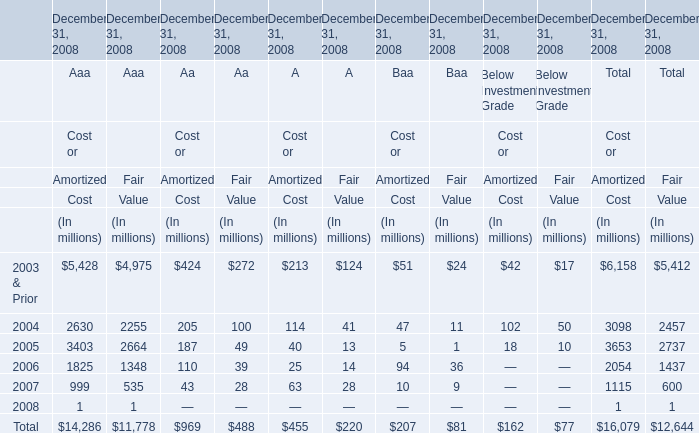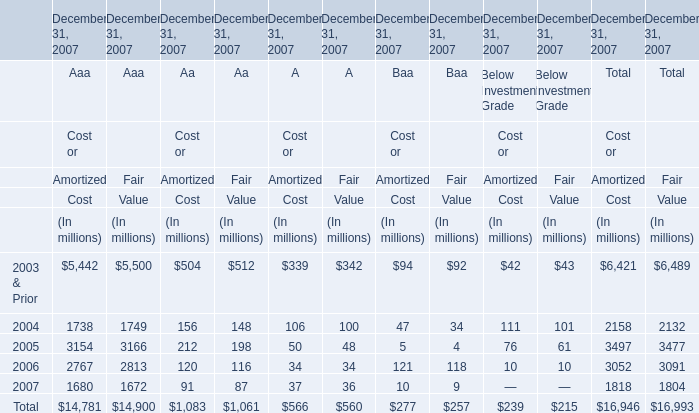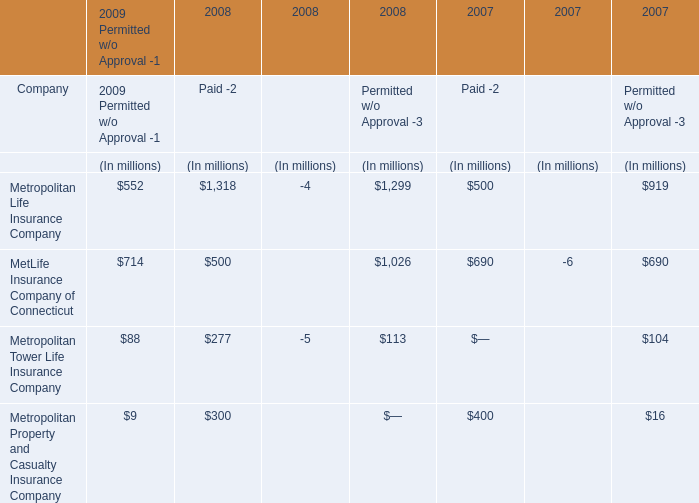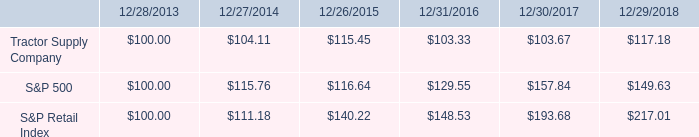Does the average value of Aaa in 2004 greater than that in 2006 for Cost? 
Answer: yes. 